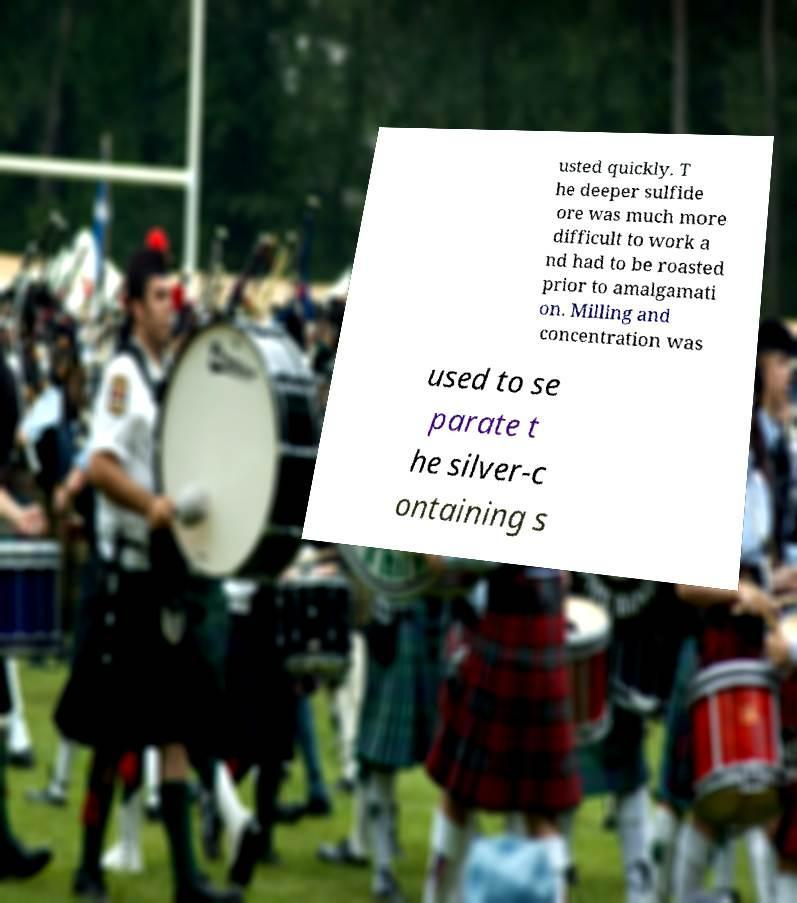Could you assist in decoding the text presented in this image and type it out clearly? usted quickly. T he deeper sulfide ore was much more difficult to work a nd had to be roasted prior to amalgamati on. Milling and concentration was used to se parate t he silver-c ontaining s 